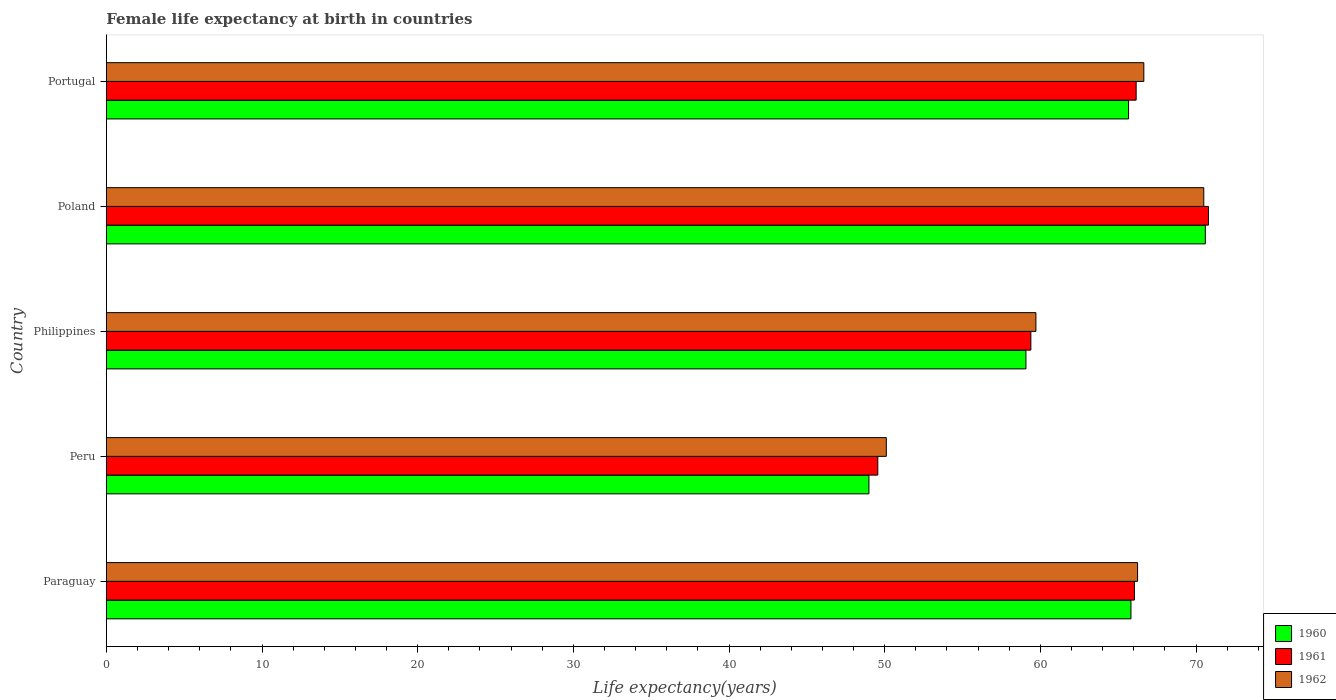Are the number of bars per tick equal to the number of legend labels?
Ensure brevity in your answer.  Yes. Are the number of bars on each tick of the Y-axis equal?
Make the answer very short. Yes. How many bars are there on the 5th tick from the top?
Ensure brevity in your answer.  3. How many bars are there on the 4th tick from the bottom?
Ensure brevity in your answer.  3. What is the female life expectancy at birth in 1961 in Paraguay?
Provide a succinct answer. 66.04. Across all countries, what is the maximum female life expectancy at birth in 1960?
Give a very brief answer. 70.6. Across all countries, what is the minimum female life expectancy at birth in 1962?
Your response must be concise. 50.11. In which country was the female life expectancy at birth in 1961 maximum?
Offer a terse response. Poland. In which country was the female life expectancy at birth in 1961 minimum?
Offer a very short reply. Peru. What is the total female life expectancy at birth in 1960 in the graph?
Your answer should be very brief. 310.15. What is the difference between the female life expectancy at birth in 1962 in Poland and that in Portugal?
Your answer should be compact. 3.85. What is the difference between the female life expectancy at birth in 1962 in Portugal and the female life expectancy at birth in 1960 in Paraguay?
Your answer should be very brief. 0.83. What is the average female life expectancy at birth in 1961 per country?
Your answer should be very brief. 62.39. What is the difference between the female life expectancy at birth in 1960 and female life expectancy at birth in 1962 in Peru?
Offer a terse response. -1.12. What is the ratio of the female life expectancy at birth in 1961 in Paraguay to that in Portugal?
Provide a short and direct response. 1. Is the female life expectancy at birth in 1960 in Paraguay less than that in Peru?
Give a very brief answer. No. What is the difference between the highest and the second highest female life expectancy at birth in 1961?
Make the answer very short. 4.64. What is the difference between the highest and the lowest female life expectancy at birth in 1961?
Offer a terse response. 21.24. Is the sum of the female life expectancy at birth in 1961 in Paraguay and Philippines greater than the maximum female life expectancy at birth in 1962 across all countries?
Provide a succinct answer. Yes. What does the 1st bar from the bottom in Philippines represents?
Offer a terse response. 1960. Is it the case that in every country, the sum of the female life expectancy at birth in 1960 and female life expectancy at birth in 1962 is greater than the female life expectancy at birth in 1961?
Give a very brief answer. Yes. How many bars are there?
Provide a succinct answer. 15. Are all the bars in the graph horizontal?
Your answer should be very brief. Yes. How many countries are there in the graph?
Your answer should be compact. 5. What is the difference between two consecutive major ticks on the X-axis?
Make the answer very short. 10. Does the graph contain grids?
Make the answer very short. No. Where does the legend appear in the graph?
Keep it short and to the point. Bottom right. How are the legend labels stacked?
Keep it short and to the point. Vertical. What is the title of the graph?
Make the answer very short. Female life expectancy at birth in countries. Does "1985" appear as one of the legend labels in the graph?
Make the answer very short. No. What is the label or title of the X-axis?
Ensure brevity in your answer.  Life expectancy(years). What is the label or title of the Y-axis?
Offer a very short reply. Country. What is the Life expectancy(years) in 1960 in Paraguay?
Your response must be concise. 65.82. What is the Life expectancy(years) in 1961 in Paraguay?
Your answer should be compact. 66.04. What is the Life expectancy(years) of 1962 in Paraguay?
Your response must be concise. 66.25. What is the Life expectancy(years) in 1960 in Peru?
Provide a succinct answer. 48.99. What is the Life expectancy(years) in 1961 in Peru?
Provide a succinct answer. 49.56. What is the Life expectancy(years) of 1962 in Peru?
Make the answer very short. 50.11. What is the Life expectancy(years) of 1960 in Philippines?
Your response must be concise. 59.08. What is the Life expectancy(years) of 1961 in Philippines?
Your answer should be very brief. 59.39. What is the Life expectancy(years) of 1962 in Philippines?
Offer a very short reply. 59.72. What is the Life expectancy(years) of 1960 in Poland?
Provide a short and direct response. 70.6. What is the Life expectancy(years) in 1961 in Poland?
Give a very brief answer. 70.8. What is the Life expectancy(years) in 1962 in Poland?
Keep it short and to the point. 70.5. What is the Life expectancy(years) of 1960 in Portugal?
Make the answer very short. 65.67. What is the Life expectancy(years) of 1961 in Portugal?
Your response must be concise. 66.16. What is the Life expectancy(years) of 1962 in Portugal?
Your answer should be very brief. 66.65. Across all countries, what is the maximum Life expectancy(years) of 1960?
Your answer should be very brief. 70.6. Across all countries, what is the maximum Life expectancy(years) in 1961?
Your response must be concise. 70.8. Across all countries, what is the maximum Life expectancy(years) in 1962?
Your answer should be compact. 70.5. Across all countries, what is the minimum Life expectancy(years) of 1960?
Give a very brief answer. 48.99. Across all countries, what is the minimum Life expectancy(years) in 1961?
Provide a succinct answer. 49.56. Across all countries, what is the minimum Life expectancy(years) in 1962?
Offer a very short reply. 50.11. What is the total Life expectancy(years) of 1960 in the graph?
Keep it short and to the point. 310.15. What is the total Life expectancy(years) in 1961 in the graph?
Give a very brief answer. 311.95. What is the total Life expectancy(years) of 1962 in the graph?
Provide a short and direct response. 313.22. What is the difference between the Life expectancy(years) in 1960 in Paraguay and that in Peru?
Keep it short and to the point. 16.83. What is the difference between the Life expectancy(years) in 1961 in Paraguay and that in Peru?
Ensure brevity in your answer.  16.48. What is the difference between the Life expectancy(years) of 1962 in Paraguay and that in Peru?
Keep it short and to the point. 16.14. What is the difference between the Life expectancy(years) in 1960 in Paraguay and that in Philippines?
Your answer should be compact. 6.75. What is the difference between the Life expectancy(years) in 1961 in Paraguay and that in Philippines?
Offer a terse response. 6.65. What is the difference between the Life expectancy(years) in 1962 in Paraguay and that in Philippines?
Make the answer very short. 6.53. What is the difference between the Life expectancy(years) of 1960 in Paraguay and that in Poland?
Your answer should be very brief. -4.78. What is the difference between the Life expectancy(years) of 1961 in Paraguay and that in Poland?
Give a very brief answer. -4.76. What is the difference between the Life expectancy(years) in 1962 in Paraguay and that in Poland?
Provide a succinct answer. -4.25. What is the difference between the Life expectancy(years) in 1960 in Paraguay and that in Portugal?
Provide a short and direct response. 0.15. What is the difference between the Life expectancy(years) in 1961 in Paraguay and that in Portugal?
Your answer should be compact. -0.11. What is the difference between the Life expectancy(years) in 1962 in Paraguay and that in Portugal?
Ensure brevity in your answer.  -0.4. What is the difference between the Life expectancy(years) in 1960 in Peru and that in Philippines?
Your answer should be compact. -10.09. What is the difference between the Life expectancy(years) of 1961 in Peru and that in Philippines?
Offer a terse response. -9.83. What is the difference between the Life expectancy(years) in 1962 in Peru and that in Philippines?
Your answer should be compact. -9.61. What is the difference between the Life expectancy(years) in 1960 in Peru and that in Poland?
Offer a very short reply. -21.61. What is the difference between the Life expectancy(years) in 1961 in Peru and that in Poland?
Offer a very short reply. -21.24. What is the difference between the Life expectancy(years) in 1962 in Peru and that in Poland?
Your answer should be compact. -20.39. What is the difference between the Life expectancy(years) in 1960 in Peru and that in Portugal?
Provide a short and direct response. -16.68. What is the difference between the Life expectancy(years) in 1961 in Peru and that in Portugal?
Offer a very short reply. -16.6. What is the difference between the Life expectancy(years) in 1962 in Peru and that in Portugal?
Offer a very short reply. -16.54. What is the difference between the Life expectancy(years) in 1960 in Philippines and that in Poland?
Your answer should be very brief. -11.53. What is the difference between the Life expectancy(years) of 1961 in Philippines and that in Poland?
Your response must be concise. -11.41. What is the difference between the Life expectancy(years) in 1962 in Philippines and that in Poland?
Ensure brevity in your answer.  -10.78. What is the difference between the Life expectancy(years) of 1960 in Philippines and that in Portugal?
Your answer should be very brief. -6.59. What is the difference between the Life expectancy(years) of 1961 in Philippines and that in Portugal?
Your answer should be compact. -6.76. What is the difference between the Life expectancy(years) of 1962 in Philippines and that in Portugal?
Provide a short and direct response. -6.93. What is the difference between the Life expectancy(years) of 1960 in Poland and that in Portugal?
Offer a terse response. 4.93. What is the difference between the Life expectancy(years) of 1961 in Poland and that in Portugal?
Ensure brevity in your answer.  4.64. What is the difference between the Life expectancy(years) of 1962 in Poland and that in Portugal?
Your answer should be compact. 3.85. What is the difference between the Life expectancy(years) of 1960 in Paraguay and the Life expectancy(years) of 1961 in Peru?
Offer a terse response. 16.26. What is the difference between the Life expectancy(years) of 1960 in Paraguay and the Life expectancy(years) of 1962 in Peru?
Offer a terse response. 15.72. What is the difference between the Life expectancy(years) of 1961 in Paraguay and the Life expectancy(years) of 1962 in Peru?
Your answer should be very brief. 15.94. What is the difference between the Life expectancy(years) of 1960 in Paraguay and the Life expectancy(years) of 1961 in Philippines?
Provide a short and direct response. 6.43. What is the difference between the Life expectancy(years) of 1960 in Paraguay and the Life expectancy(years) of 1962 in Philippines?
Your answer should be compact. 6.11. What is the difference between the Life expectancy(years) in 1961 in Paraguay and the Life expectancy(years) in 1962 in Philippines?
Make the answer very short. 6.33. What is the difference between the Life expectancy(years) of 1960 in Paraguay and the Life expectancy(years) of 1961 in Poland?
Provide a short and direct response. -4.98. What is the difference between the Life expectancy(years) in 1960 in Paraguay and the Life expectancy(years) in 1962 in Poland?
Provide a short and direct response. -4.68. What is the difference between the Life expectancy(years) in 1961 in Paraguay and the Life expectancy(years) in 1962 in Poland?
Your answer should be very brief. -4.46. What is the difference between the Life expectancy(years) in 1960 in Paraguay and the Life expectancy(years) in 1961 in Portugal?
Ensure brevity in your answer.  -0.33. What is the difference between the Life expectancy(years) in 1960 in Paraguay and the Life expectancy(years) in 1962 in Portugal?
Provide a succinct answer. -0.83. What is the difference between the Life expectancy(years) of 1961 in Paraguay and the Life expectancy(years) of 1962 in Portugal?
Your response must be concise. -0.6. What is the difference between the Life expectancy(years) in 1960 in Peru and the Life expectancy(years) in 1961 in Philippines?
Make the answer very short. -10.4. What is the difference between the Life expectancy(years) of 1960 in Peru and the Life expectancy(years) of 1962 in Philippines?
Offer a very short reply. -10.73. What is the difference between the Life expectancy(years) in 1961 in Peru and the Life expectancy(years) in 1962 in Philippines?
Your answer should be very brief. -10.16. What is the difference between the Life expectancy(years) in 1960 in Peru and the Life expectancy(years) in 1961 in Poland?
Ensure brevity in your answer.  -21.81. What is the difference between the Life expectancy(years) of 1960 in Peru and the Life expectancy(years) of 1962 in Poland?
Make the answer very short. -21.51. What is the difference between the Life expectancy(years) in 1961 in Peru and the Life expectancy(years) in 1962 in Poland?
Offer a terse response. -20.94. What is the difference between the Life expectancy(years) in 1960 in Peru and the Life expectancy(years) in 1961 in Portugal?
Provide a short and direct response. -17.17. What is the difference between the Life expectancy(years) of 1960 in Peru and the Life expectancy(years) of 1962 in Portugal?
Your answer should be compact. -17.66. What is the difference between the Life expectancy(years) of 1961 in Peru and the Life expectancy(years) of 1962 in Portugal?
Offer a very short reply. -17.09. What is the difference between the Life expectancy(years) of 1960 in Philippines and the Life expectancy(years) of 1961 in Poland?
Make the answer very short. -11.72. What is the difference between the Life expectancy(years) in 1960 in Philippines and the Life expectancy(years) in 1962 in Poland?
Your answer should be very brief. -11.43. What is the difference between the Life expectancy(years) in 1961 in Philippines and the Life expectancy(years) in 1962 in Poland?
Ensure brevity in your answer.  -11.11. What is the difference between the Life expectancy(years) of 1960 in Philippines and the Life expectancy(years) of 1961 in Portugal?
Give a very brief answer. -7.08. What is the difference between the Life expectancy(years) in 1960 in Philippines and the Life expectancy(years) in 1962 in Portugal?
Your answer should be very brief. -7.57. What is the difference between the Life expectancy(years) of 1961 in Philippines and the Life expectancy(years) of 1962 in Portugal?
Provide a succinct answer. -7.26. What is the difference between the Life expectancy(years) of 1960 in Poland and the Life expectancy(years) of 1961 in Portugal?
Your response must be concise. 4.44. What is the difference between the Life expectancy(years) in 1960 in Poland and the Life expectancy(years) in 1962 in Portugal?
Provide a short and direct response. 3.95. What is the difference between the Life expectancy(years) of 1961 in Poland and the Life expectancy(years) of 1962 in Portugal?
Keep it short and to the point. 4.15. What is the average Life expectancy(years) of 1960 per country?
Offer a very short reply. 62.03. What is the average Life expectancy(years) in 1961 per country?
Give a very brief answer. 62.39. What is the average Life expectancy(years) in 1962 per country?
Offer a very short reply. 62.64. What is the difference between the Life expectancy(years) in 1960 and Life expectancy(years) in 1961 in Paraguay?
Provide a short and direct response. -0.22. What is the difference between the Life expectancy(years) in 1960 and Life expectancy(years) in 1962 in Paraguay?
Your answer should be compact. -0.42. What is the difference between the Life expectancy(years) in 1961 and Life expectancy(years) in 1962 in Paraguay?
Provide a succinct answer. -0.2. What is the difference between the Life expectancy(years) of 1960 and Life expectancy(years) of 1961 in Peru?
Provide a short and direct response. -0.57. What is the difference between the Life expectancy(years) in 1960 and Life expectancy(years) in 1962 in Peru?
Keep it short and to the point. -1.12. What is the difference between the Life expectancy(years) of 1961 and Life expectancy(years) of 1962 in Peru?
Offer a terse response. -0.55. What is the difference between the Life expectancy(years) in 1960 and Life expectancy(years) in 1961 in Philippines?
Make the answer very short. -0.32. What is the difference between the Life expectancy(years) in 1960 and Life expectancy(years) in 1962 in Philippines?
Offer a terse response. -0.64. What is the difference between the Life expectancy(years) in 1961 and Life expectancy(years) in 1962 in Philippines?
Offer a very short reply. -0.32. What is the difference between the Life expectancy(years) of 1960 and Life expectancy(years) of 1961 in Poland?
Give a very brief answer. -0.2. What is the difference between the Life expectancy(years) in 1960 and Life expectancy(years) in 1962 in Poland?
Your response must be concise. 0.1. What is the difference between the Life expectancy(years) in 1961 and Life expectancy(years) in 1962 in Poland?
Make the answer very short. 0.3. What is the difference between the Life expectancy(years) in 1960 and Life expectancy(years) in 1961 in Portugal?
Give a very brief answer. -0.49. What is the difference between the Life expectancy(years) in 1960 and Life expectancy(years) in 1962 in Portugal?
Your answer should be compact. -0.98. What is the difference between the Life expectancy(years) in 1961 and Life expectancy(years) in 1962 in Portugal?
Offer a very short reply. -0.49. What is the ratio of the Life expectancy(years) of 1960 in Paraguay to that in Peru?
Offer a very short reply. 1.34. What is the ratio of the Life expectancy(years) in 1961 in Paraguay to that in Peru?
Your response must be concise. 1.33. What is the ratio of the Life expectancy(years) of 1962 in Paraguay to that in Peru?
Provide a short and direct response. 1.32. What is the ratio of the Life expectancy(years) in 1960 in Paraguay to that in Philippines?
Make the answer very short. 1.11. What is the ratio of the Life expectancy(years) of 1961 in Paraguay to that in Philippines?
Make the answer very short. 1.11. What is the ratio of the Life expectancy(years) in 1962 in Paraguay to that in Philippines?
Provide a succinct answer. 1.11. What is the ratio of the Life expectancy(years) in 1960 in Paraguay to that in Poland?
Make the answer very short. 0.93. What is the ratio of the Life expectancy(years) of 1961 in Paraguay to that in Poland?
Your answer should be compact. 0.93. What is the ratio of the Life expectancy(years) in 1962 in Paraguay to that in Poland?
Ensure brevity in your answer.  0.94. What is the ratio of the Life expectancy(years) of 1960 in Paraguay to that in Portugal?
Provide a short and direct response. 1. What is the ratio of the Life expectancy(years) of 1962 in Paraguay to that in Portugal?
Give a very brief answer. 0.99. What is the ratio of the Life expectancy(years) of 1960 in Peru to that in Philippines?
Keep it short and to the point. 0.83. What is the ratio of the Life expectancy(years) of 1961 in Peru to that in Philippines?
Keep it short and to the point. 0.83. What is the ratio of the Life expectancy(years) of 1962 in Peru to that in Philippines?
Ensure brevity in your answer.  0.84. What is the ratio of the Life expectancy(years) in 1960 in Peru to that in Poland?
Provide a short and direct response. 0.69. What is the ratio of the Life expectancy(years) in 1962 in Peru to that in Poland?
Give a very brief answer. 0.71. What is the ratio of the Life expectancy(years) of 1960 in Peru to that in Portugal?
Keep it short and to the point. 0.75. What is the ratio of the Life expectancy(years) in 1961 in Peru to that in Portugal?
Ensure brevity in your answer.  0.75. What is the ratio of the Life expectancy(years) in 1962 in Peru to that in Portugal?
Ensure brevity in your answer.  0.75. What is the ratio of the Life expectancy(years) in 1960 in Philippines to that in Poland?
Keep it short and to the point. 0.84. What is the ratio of the Life expectancy(years) in 1961 in Philippines to that in Poland?
Keep it short and to the point. 0.84. What is the ratio of the Life expectancy(years) in 1962 in Philippines to that in Poland?
Provide a succinct answer. 0.85. What is the ratio of the Life expectancy(years) of 1960 in Philippines to that in Portugal?
Your response must be concise. 0.9. What is the ratio of the Life expectancy(years) of 1961 in Philippines to that in Portugal?
Make the answer very short. 0.9. What is the ratio of the Life expectancy(years) in 1962 in Philippines to that in Portugal?
Give a very brief answer. 0.9. What is the ratio of the Life expectancy(years) of 1960 in Poland to that in Portugal?
Provide a succinct answer. 1.08. What is the ratio of the Life expectancy(years) of 1961 in Poland to that in Portugal?
Make the answer very short. 1.07. What is the ratio of the Life expectancy(years) of 1962 in Poland to that in Portugal?
Provide a succinct answer. 1.06. What is the difference between the highest and the second highest Life expectancy(years) in 1960?
Your answer should be compact. 4.78. What is the difference between the highest and the second highest Life expectancy(years) of 1961?
Your answer should be compact. 4.64. What is the difference between the highest and the second highest Life expectancy(years) in 1962?
Your response must be concise. 3.85. What is the difference between the highest and the lowest Life expectancy(years) of 1960?
Provide a succinct answer. 21.61. What is the difference between the highest and the lowest Life expectancy(years) in 1961?
Provide a succinct answer. 21.24. What is the difference between the highest and the lowest Life expectancy(years) in 1962?
Provide a short and direct response. 20.39. 